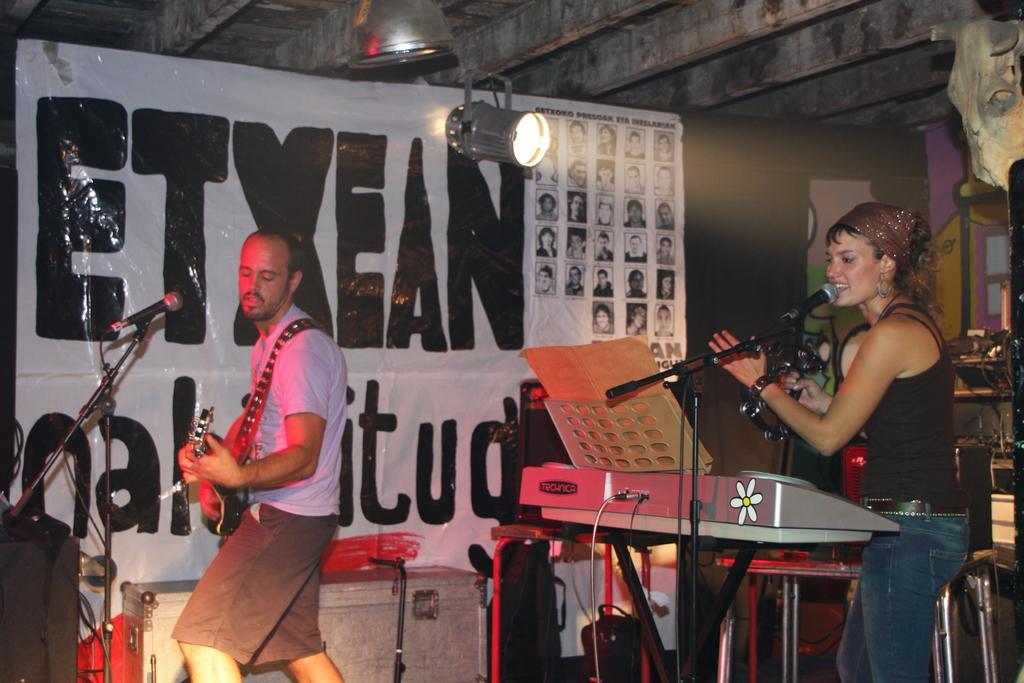Could you give a brief overview of what you see in this image? 2 people are standing. the person at the left is playing guitar. behind them there is a banner on which etxeal is written. above that a light is present. 